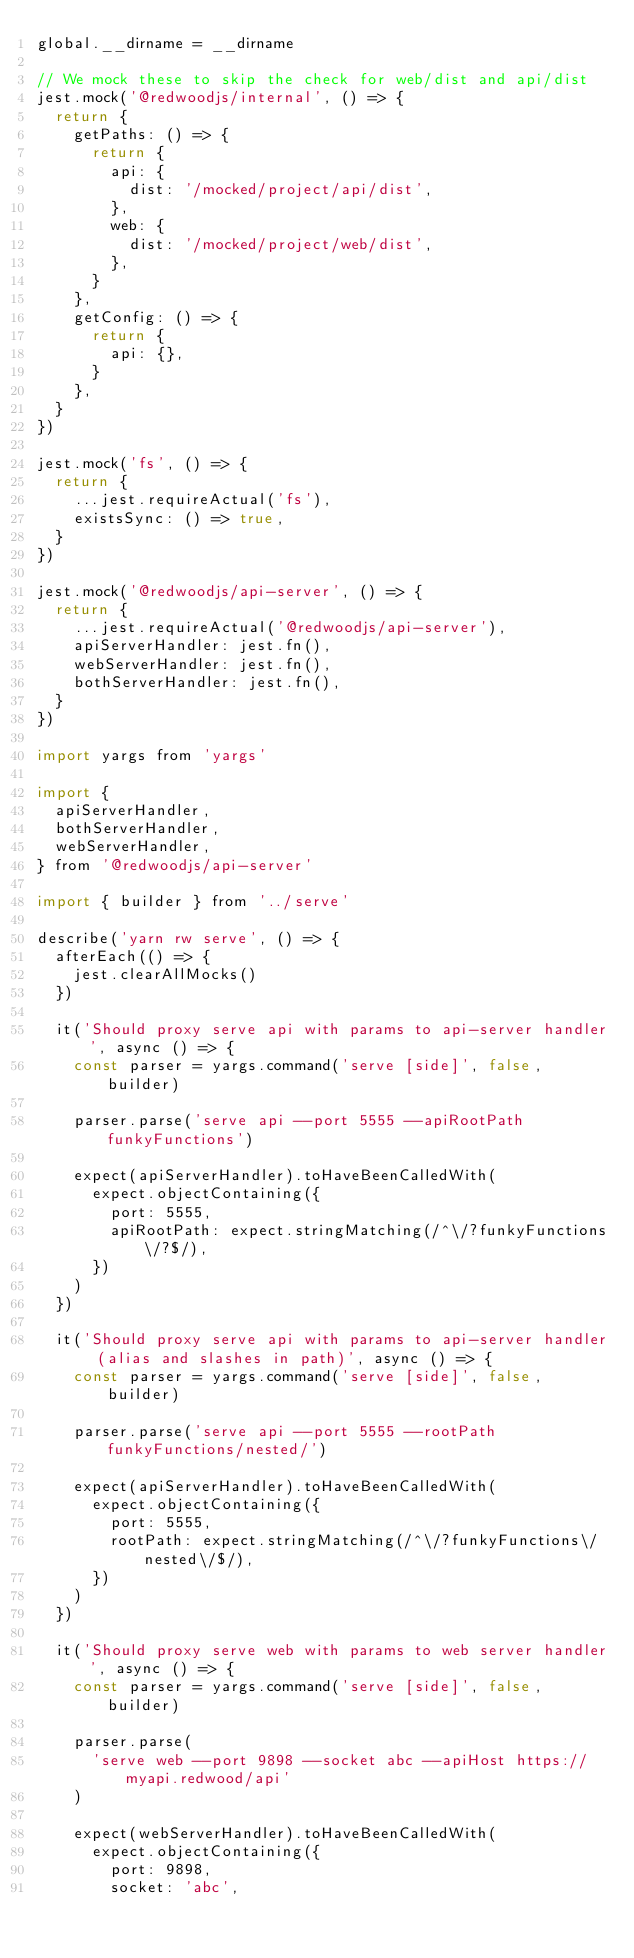<code> <loc_0><loc_0><loc_500><loc_500><_JavaScript_>global.__dirname = __dirname

// We mock these to skip the check for web/dist and api/dist
jest.mock('@redwoodjs/internal', () => {
  return {
    getPaths: () => {
      return {
        api: {
          dist: '/mocked/project/api/dist',
        },
        web: {
          dist: '/mocked/project/web/dist',
        },
      }
    },
    getConfig: () => {
      return {
        api: {},
      }
    },
  }
})

jest.mock('fs', () => {
  return {
    ...jest.requireActual('fs'),
    existsSync: () => true,
  }
})

jest.mock('@redwoodjs/api-server', () => {
  return {
    ...jest.requireActual('@redwoodjs/api-server'),
    apiServerHandler: jest.fn(),
    webServerHandler: jest.fn(),
    bothServerHandler: jest.fn(),
  }
})

import yargs from 'yargs'

import {
  apiServerHandler,
  bothServerHandler,
  webServerHandler,
} from '@redwoodjs/api-server'

import { builder } from '../serve'

describe('yarn rw serve', () => {
  afterEach(() => {
    jest.clearAllMocks()
  })

  it('Should proxy serve api with params to api-server handler', async () => {
    const parser = yargs.command('serve [side]', false, builder)

    parser.parse('serve api --port 5555 --apiRootPath funkyFunctions')

    expect(apiServerHandler).toHaveBeenCalledWith(
      expect.objectContaining({
        port: 5555,
        apiRootPath: expect.stringMatching(/^\/?funkyFunctions\/?$/),
      })
    )
  })

  it('Should proxy serve api with params to api-server handler (alias and slashes in path)', async () => {
    const parser = yargs.command('serve [side]', false, builder)

    parser.parse('serve api --port 5555 --rootPath funkyFunctions/nested/')

    expect(apiServerHandler).toHaveBeenCalledWith(
      expect.objectContaining({
        port: 5555,
        rootPath: expect.stringMatching(/^\/?funkyFunctions\/nested\/$/),
      })
    )
  })

  it('Should proxy serve web with params to web server handler', async () => {
    const parser = yargs.command('serve [side]', false, builder)

    parser.parse(
      'serve web --port 9898 --socket abc --apiHost https://myapi.redwood/api'
    )

    expect(webServerHandler).toHaveBeenCalledWith(
      expect.objectContaining({
        port: 9898,
        socket: 'abc',</code> 